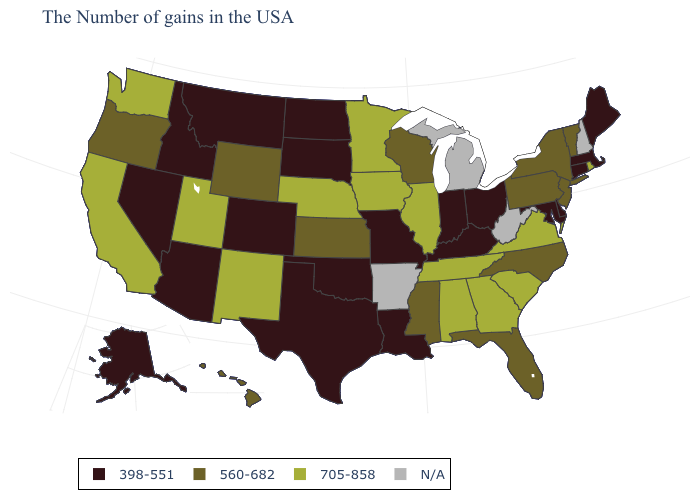Among the states that border Idaho , which have the highest value?
Quick response, please. Utah, Washington. What is the lowest value in the USA?
Short answer required. 398-551. Does the map have missing data?
Be succinct. Yes. Among the states that border New Mexico , does Utah have the highest value?
Give a very brief answer. Yes. Does Vermont have the lowest value in the USA?
Answer briefly. No. Name the states that have a value in the range 705-858?
Write a very short answer. Rhode Island, Virginia, South Carolina, Georgia, Alabama, Tennessee, Illinois, Minnesota, Iowa, Nebraska, New Mexico, Utah, California, Washington. What is the value of Hawaii?
Keep it brief. 560-682. Name the states that have a value in the range 705-858?
Be succinct. Rhode Island, Virginia, South Carolina, Georgia, Alabama, Tennessee, Illinois, Minnesota, Iowa, Nebraska, New Mexico, Utah, California, Washington. Among the states that border New York , which have the highest value?
Answer briefly. Vermont, New Jersey, Pennsylvania. Which states have the highest value in the USA?
Keep it brief. Rhode Island, Virginia, South Carolina, Georgia, Alabama, Tennessee, Illinois, Minnesota, Iowa, Nebraska, New Mexico, Utah, California, Washington. Does Florida have the lowest value in the USA?
Quick response, please. No. Name the states that have a value in the range N/A?
Short answer required. New Hampshire, West Virginia, Michigan, Arkansas. Does Tennessee have the highest value in the USA?
Short answer required. Yes. 